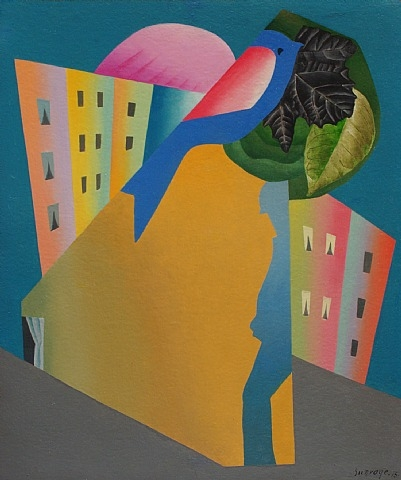What is this photo about? The image presents a striking example of abstract and surreal art. A bold palette features a deep teal backdrop against which a vivid silhouette of a human head and neck emerges in sunny yellow and orange tones. Atop this silhouette rests a vibrantly colored bird, perhaps a symbol of freedom or nature, clutching a green leaf. Surrounding the figure are stylized structures resembling buildings in soft yellows and oranges, their window-like elements suggesting an urban landscape. This artwork cleverly plays with forms and colors to evoke themes of human presence, nature, and possibly the interaction between individuality and societal constructs. 